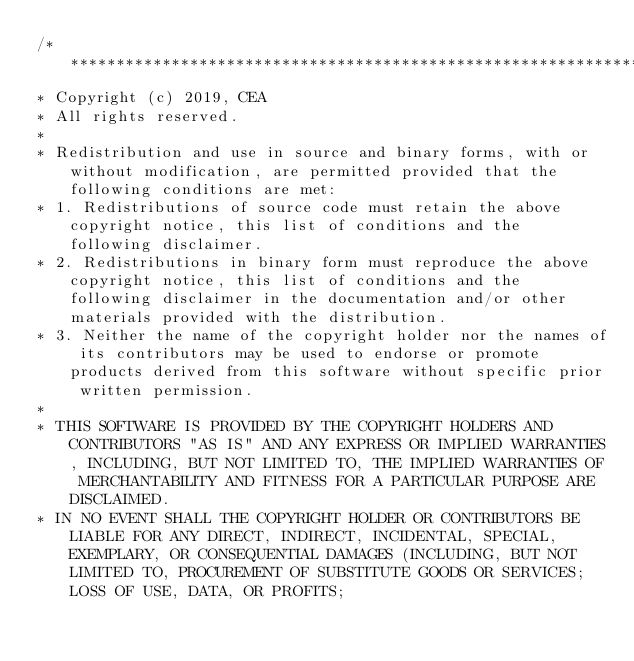<code> <loc_0><loc_0><loc_500><loc_500><_C_>/****************************************************************************
* Copyright (c) 2019, CEA
* All rights reserved.
*
* Redistribution and use in source and binary forms, with or without modification, are permitted provided that the following conditions are met:
* 1. Redistributions of source code must retain the above copyright notice, this list of conditions and the following disclaimer.
* 2. Redistributions in binary form must reproduce the above copyright notice, this list of conditions and the following disclaimer in the documentation and/or other materials provided with the distribution.
* 3. Neither the name of the copyright holder nor the names of its contributors may be used to endorse or promote products derived from this software without specific prior written permission.
*
* THIS SOFTWARE IS PROVIDED BY THE COPYRIGHT HOLDERS AND CONTRIBUTORS "AS IS" AND ANY EXPRESS OR IMPLIED WARRANTIES, INCLUDING, BUT NOT LIMITED TO, THE IMPLIED WARRANTIES OF MERCHANTABILITY AND FITNESS FOR A PARTICULAR PURPOSE ARE DISCLAIMED.
* IN NO EVENT SHALL THE COPYRIGHT HOLDER OR CONTRIBUTORS BE LIABLE FOR ANY DIRECT, INDIRECT, INCIDENTAL, SPECIAL, EXEMPLARY, OR CONSEQUENTIAL DAMAGES (INCLUDING, BUT NOT LIMITED TO, PROCUREMENT OF SUBSTITUTE GOODS OR SERVICES; LOSS OF USE, DATA, OR PROFITS;</code> 